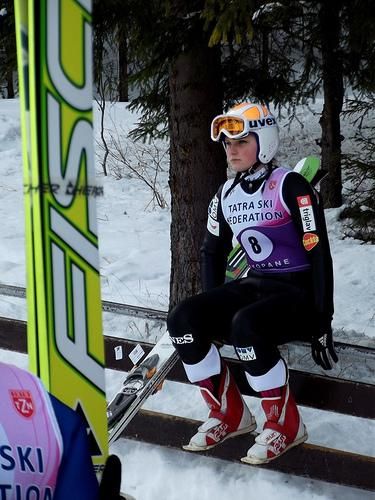Explain the purpose of the goggles and the helmet that the girl is wearing. The orange goggles are for eye protection, and the white helmet is worn for head protection. What are the objects seen in the foreground, and what is their purpose? A set of white skis and binding for snow skiing are present in the foreground, used for skiing activities. Can you list three accessories the girl is wearing and their respective colors? The girl is wearing a white helmet, orange goggles, and red shoes. Analyze the sentiment portrayed by the image based on the objects and actions present. The image portrays a joyful and exciting sentiment, as it depicts a girl enjoying snow skiing and sitting on a ledge. Determine the image quality based on the width and height of the objects captured. The image quality seems to be average, as objects have various widths and heights ranging from small to relatively large. Please provide a general description of the environment surrounding the girl. The girl is surrounded by snow on the ground, a brown tree with a thick trunk, and another snow skier in the foreground. Conduct a brief reasoning on the relationship between the girl and the environment. Assuming from the context, the girl is likely a snow skier or competitor, since she is wearing skiing gear and is surrounded by a snowy environment. Count the total number of red and white boots described in the image. There are five instances of red and white boots mentioned in the image. Identify the color of the snow skier's top and pants in the foreground. The snow skier in the foreground has a multicolored top and black pants. What color is the girl's helmet and what is she sitting on? The girl's helmet is white and she is sitting on a brown ledge or fence. Try to find a dog playing with a snowball just below the tree with a thick trunk. No, it's not mentioned in the image. 